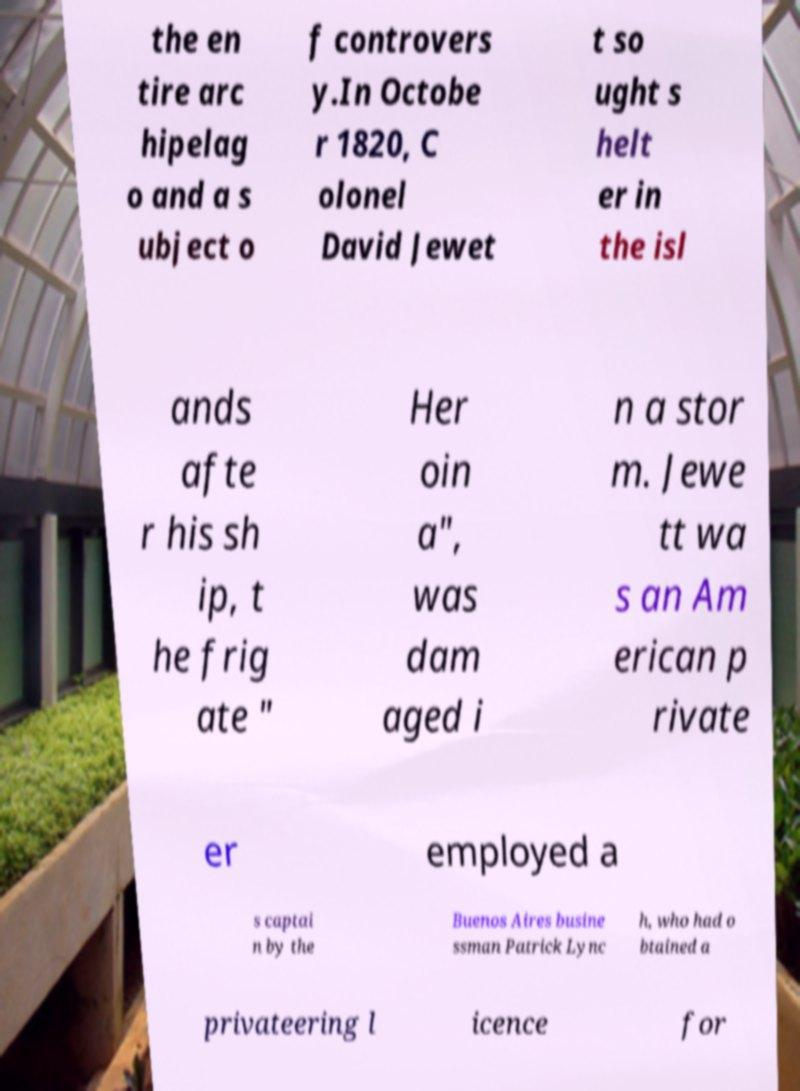Could you extract and type out the text from this image? the en tire arc hipelag o and a s ubject o f controvers y.In Octobe r 1820, C olonel David Jewet t so ught s helt er in the isl ands afte r his sh ip, t he frig ate " Her oin a", was dam aged i n a stor m. Jewe tt wa s an Am erican p rivate er employed a s captai n by the Buenos Aires busine ssman Patrick Lync h, who had o btained a privateering l icence for 